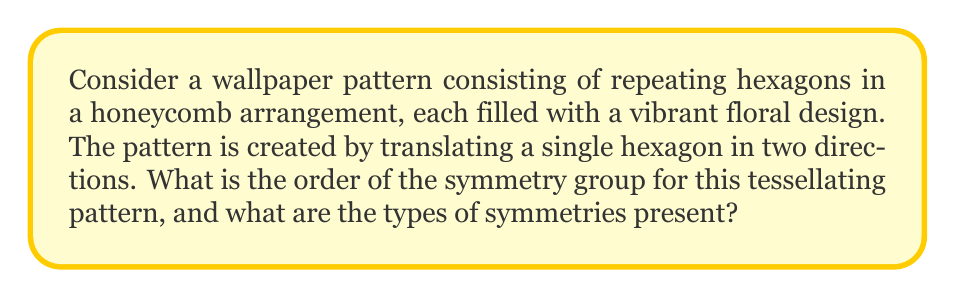Could you help me with this problem? To analyze the symmetry group of this tessellating pattern, we need to consider the following steps:

1. Identify the lattice structure:
   The pattern forms a hexagonal lattice, which can be described by two translation vectors.

2. Determine the point group symmetries of a single motif (hexagon):
   A regular hexagon has 12 symmetries:
   - 6 rotational symmetries (including the identity): $0°, 60°, 120°, 180°, 240°, 300°$
   - 6 reflection symmetries (3 through vertices, 3 through midpoints of edges)

3. Analyze the wallpaper group:
   This pattern corresponds to the wallpaper group p6m, which is the most symmetric of the 17 wallpaper groups.

4. List the symmetry operations:
   a) Translations: Infinite number of translations in two independent directions
   b) Rotations: $60°, 120°, 180°$ around hexagon centers
   c) Reflections: Across lines connecting hexagon centers
   d) Glide reflections: Combination of reflection and translation

5. Calculate the order of the symmetry group:
   The symmetry group of a wallpaper pattern has infinite order due to the infinite number of translations. However, we can consider the quotient group obtained by modding out the translation subgroup.

   Order of the quotient group = Order of point group of hexagon = 12

Therefore, while the full symmetry group has infinite order, the essential symmetries (modulo translations) form a group of order 12.

Types of symmetries present:
1. Translational symmetry
2. Rotational symmetry (60°, 120°, 180°)
3. Reflection symmetry
4. Glide reflection symmetry
Answer: The symmetry group of the tessellating hexagonal pattern has infinite order. The quotient group obtained by modding out translations has order 12. The types of symmetries present are translational, rotational (60°, 120°, 180°), reflection, and glide reflection symmetries. 